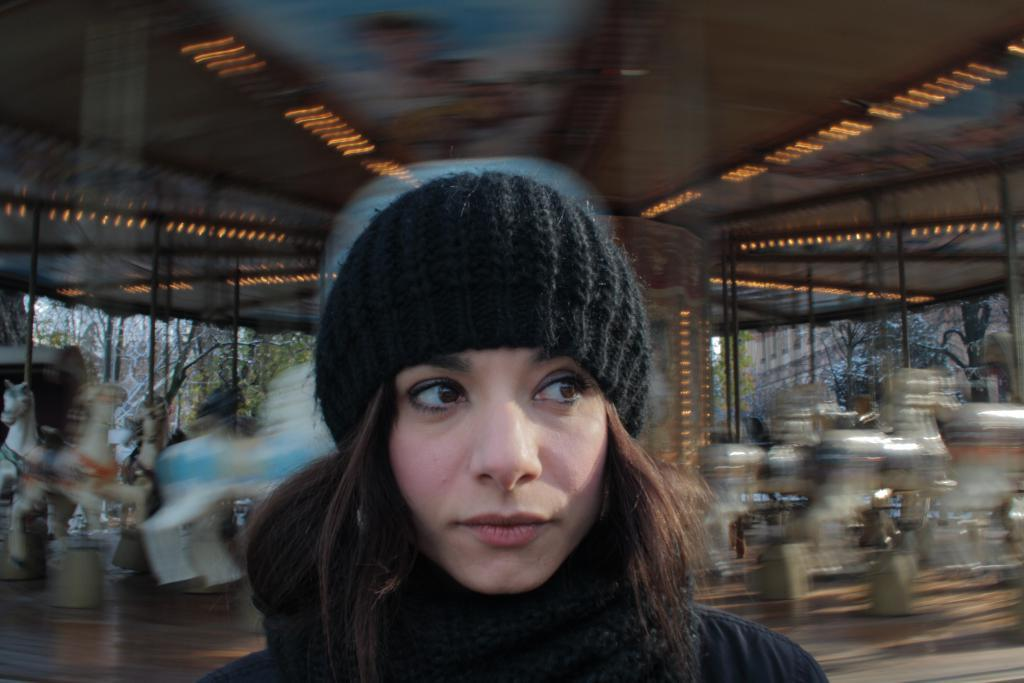Who is present in the image? There is a woman in the image. What is the woman wearing on her head? The woman is wearing a black cap. Can you describe the background of the image? The background of the image has a blurred view. What type of structure can be seen in the image? There is a merry-go-round in the image. What natural elements are visible in the image? There are trees visible in the image. What man-made structure is present in the image? There is a building in the image. What degree does the woman have in the image? There is no information about the woman's degree in the image. What type of haircut does the woman have in the image? The provided facts do not mention the woman's haircut. What songs can be heard playing in the background of the image? There is no information about any songs playing in the image. 